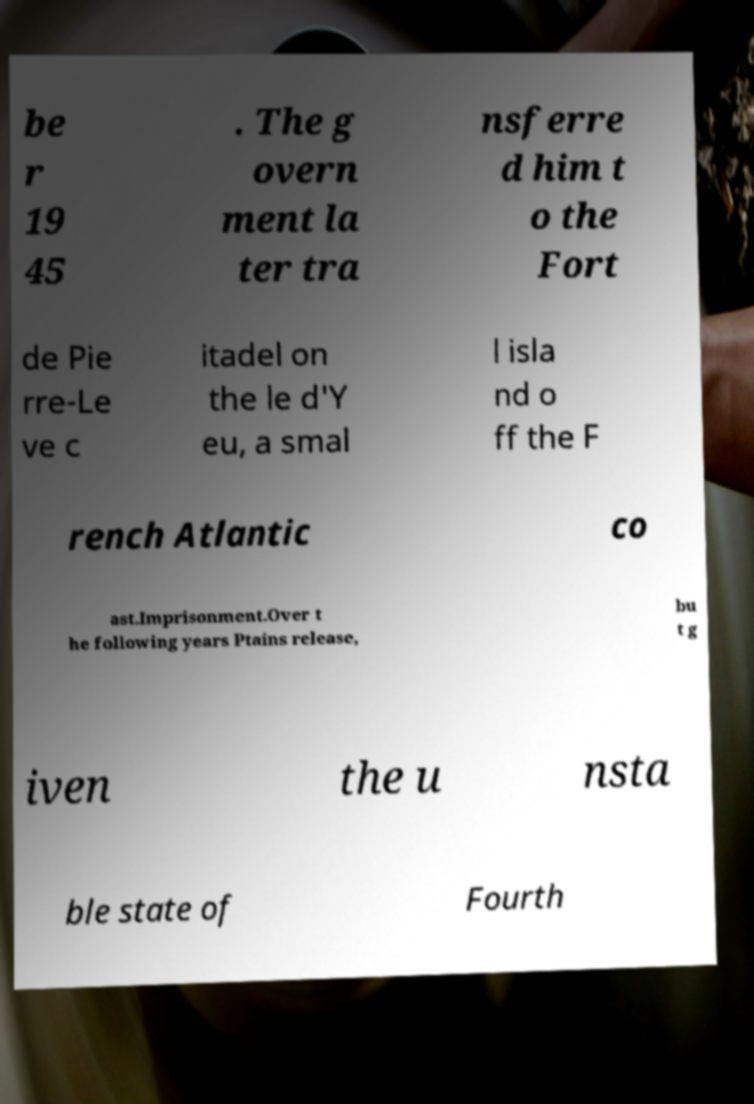For documentation purposes, I need the text within this image transcribed. Could you provide that? be r 19 45 . The g overn ment la ter tra nsferre d him t o the Fort de Pie rre-Le ve c itadel on the le d'Y eu, a smal l isla nd o ff the F rench Atlantic co ast.Imprisonment.Over t he following years Ptains release, bu t g iven the u nsta ble state of Fourth 